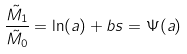Convert formula to latex. <formula><loc_0><loc_0><loc_500><loc_500>\frac { \tilde { M _ { 1 } } } { \tilde { M _ { 0 } } } = \ln ( a ) + b s = \Psi ( a )</formula> 